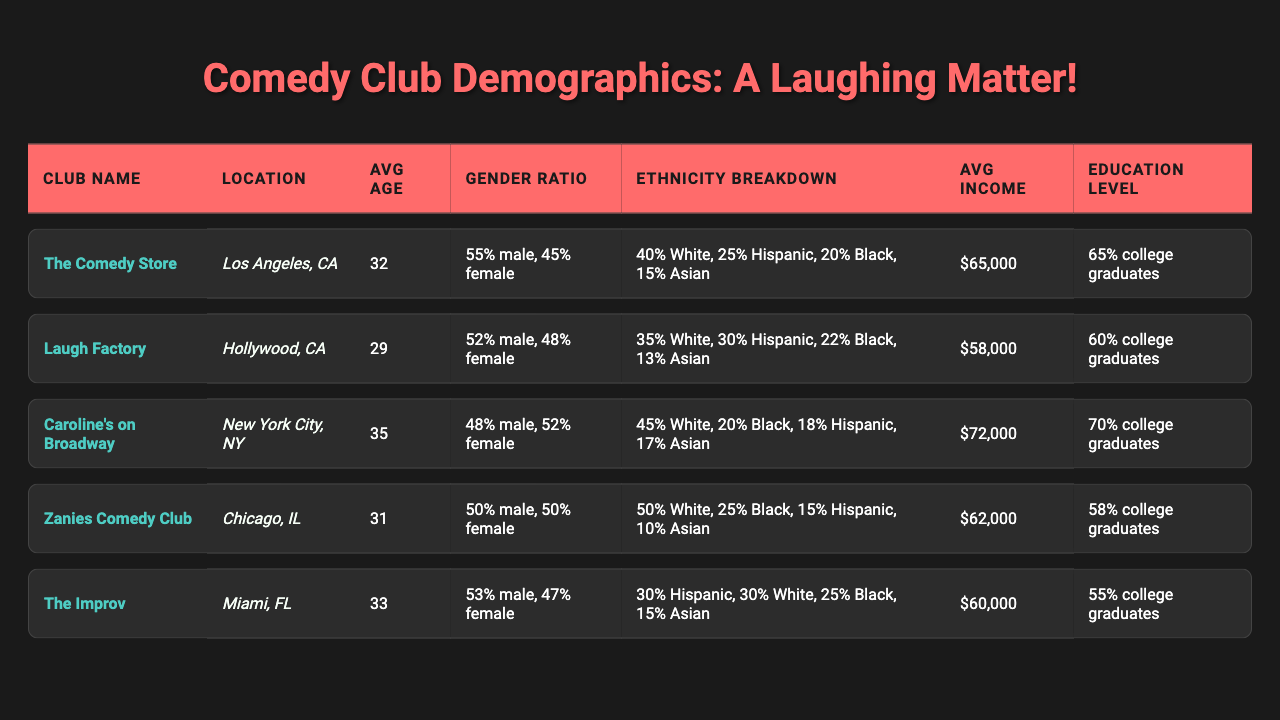What is the average age of the audience at "Caroline's on Broadway"? In the table, the average age for "Caroline's on Broadway" is given directly as 35.
Answer: 35 What is the gender ratio at "The Improv"? The gender ratio at "The Improv" is listed as 53% male and 47% female.
Answer: 53% male, 47% female Which comedy club has the highest average income? By comparing the average incomes listed, "Caroline's on Broadway" has the highest average income at $72,000.
Answer: $72,000 What percentage of the audience at "Zanies Comedy Club" are college graduates? The table specifies that 58% of the audience at "Zanies Comedy Club" are college graduates.
Answer: 58% Is the average age of the audience at "Laugh Factory" lower than that at "The Comedy Store"? The average age at "Laugh Factory" is 29, while at "The Comedy Store" it is 32. Since 29 is less than 32, the statement is true.
Answer: Yes Calculate the average income of all listed comedy clubs. To find the average income, first convert the incomes: $65,000, $58,000, $72,000, $62,000, and $60,000. Sum them up: 65,000 + 58,000 + 72,000 + 62,000 + 60,000 = 317,000. Then divide by 5 (the number of clubs): 317,000 / 5 = 63,400.
Answer: $63,400 Does "Laugh Factory" have a higher percentage of White audience than "The Improv"? "Laugh Factory" has 35% White audience while "The Improv" has 30%. Since 35% is greater than 30%, the statement is true.
Answer: Yes What is the ethnicity breakdown of the audience at "The Comedy Store"? The ethnicity breakdown for "The Comedy Store" is listed as 40% White, 25% Hispanic, 20% Black, and 15% Asian.
Answer: 40% White, 25% Hispanic, 20% Black, 15% Asian Which club has the highest percentage of female audience members? The club with the highest percentage of female audience members is "Caroline's on Broadway," with 52% female.
Answer: "Caroline's on Broadway" How does the average age of the audience at "Zanies Comedy Club" compare to the average age at "The Improv"? "Zanies Comedy Club" has an average age of 31, while "The Improv" has an average age of 33. Since 31 is less than 33, the average age at Zanies is lower.
Answer: Lower What is the total percentage of Black audience members across all clubs? By adding the percentages: 20% (Caroline's) + 25% (Zanies) + 25% (The Improv) + 22% (Laugh Factory) + 0% (The Comedy Store) = 92%. However, only "Caroline's", "Zanies", "The Improv" and "Laugh Factory" have Black audience members so the valid total is 20% + 25% + 25% + 22% = 92%/4= 23% on average for being form clubs that they attended.
Answer: 23% 